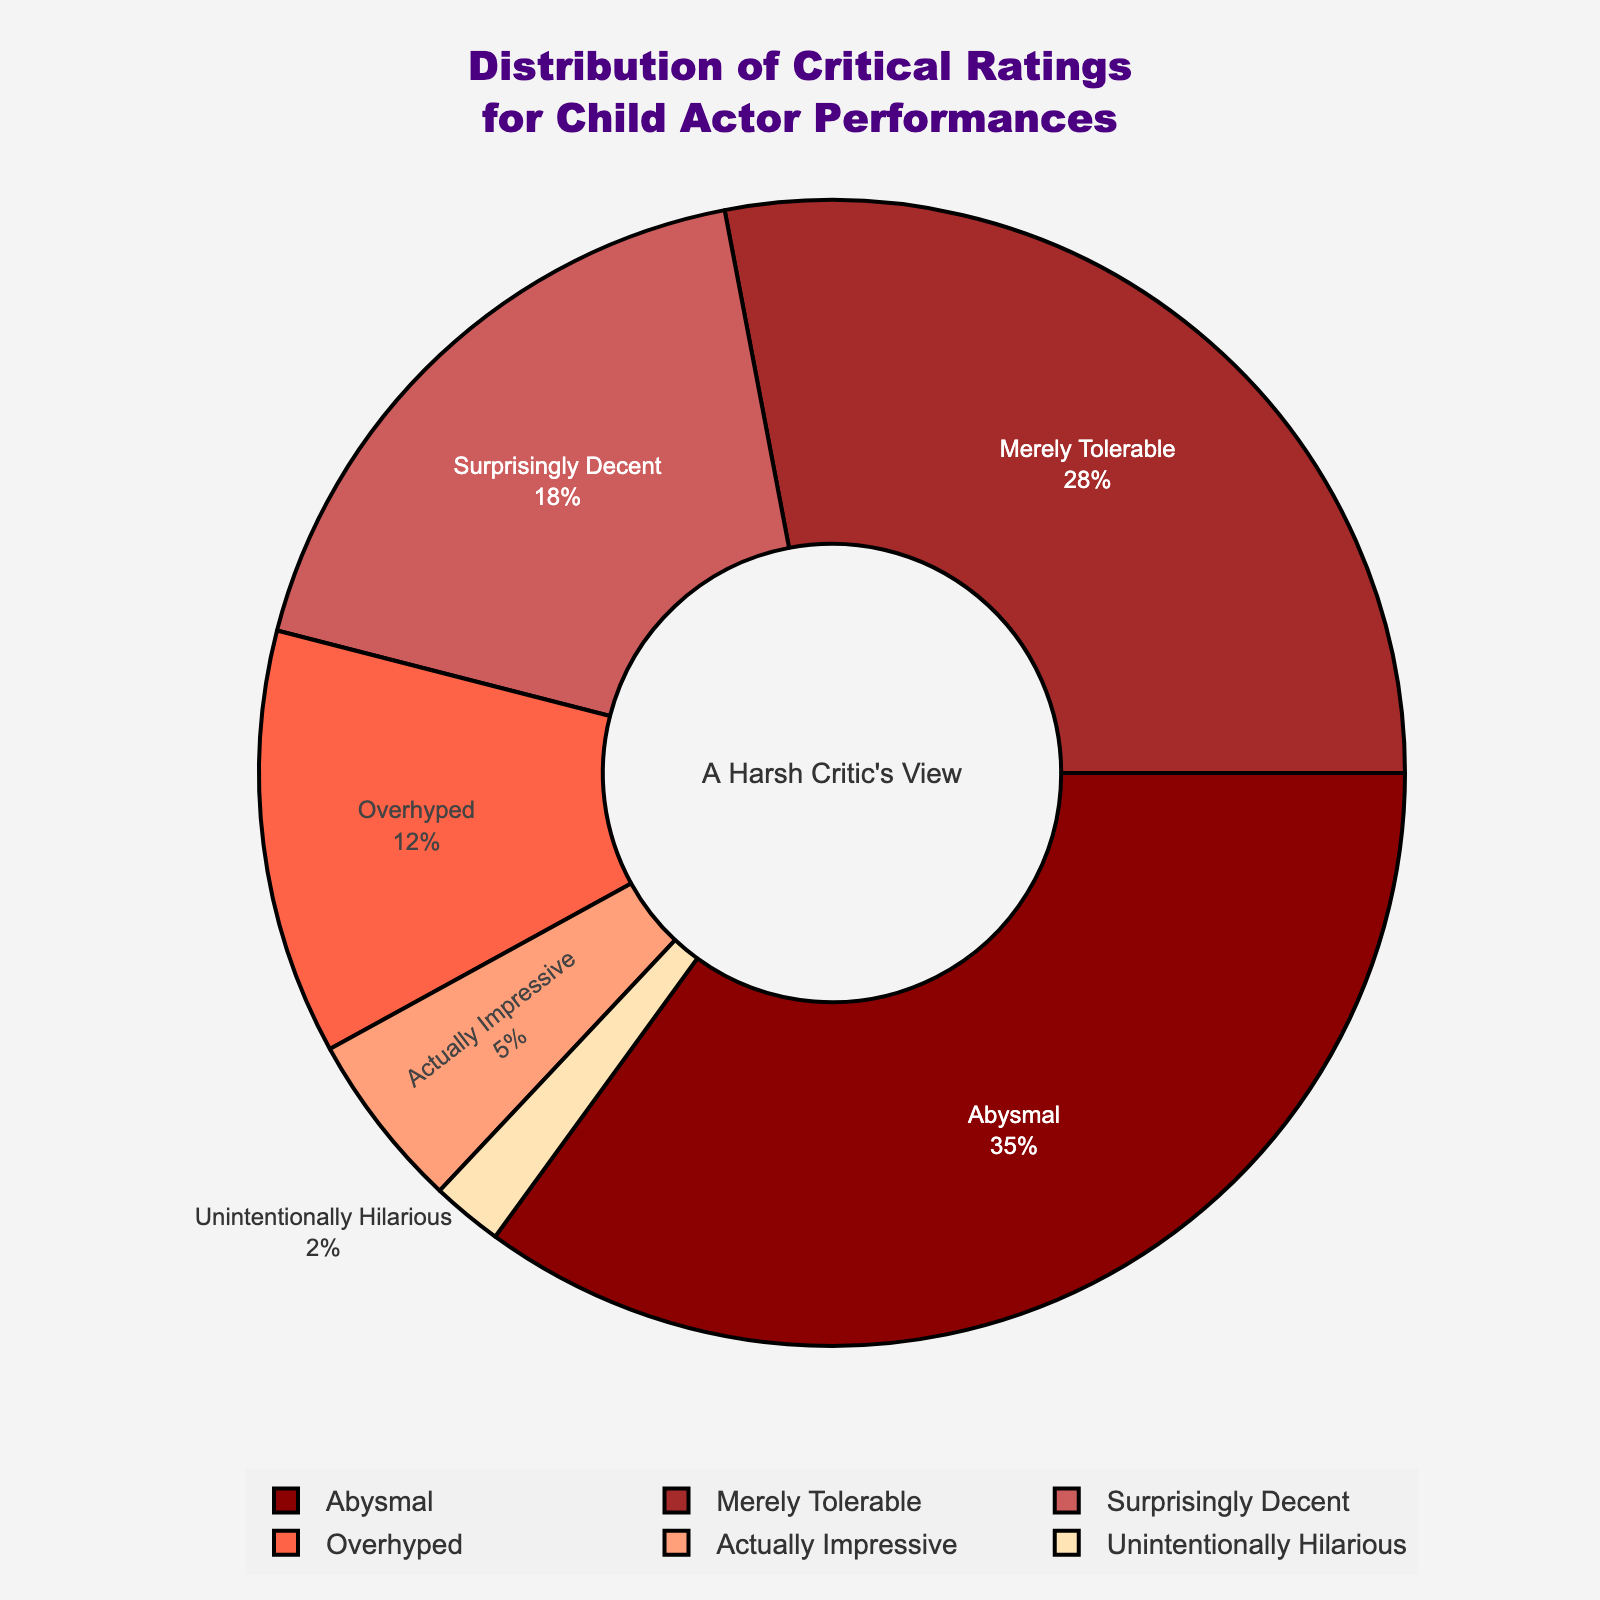What percentage of critical ratings fall into categories that are less than 'Surprisingly Decent'? Add up the percentages of 'Abysmal' (35%) and 'Merely Tolerable' (28%). 35 + 28 = 63%
Answer: 63% Which rating category received the smallest percentage of ratings? Observe the pie chart and note that 'Unintentionally Hilarious' has the smallest slice.
Answer: Unintentionally Hilarious How much greater is the percentage for 'Abysmal' compared to 'Actually Impressive'? Subtract the percentage of 'Actually Impressive' (5%) from 'Abysmal' (35%). 35 - 5 = 30%
Answer: 30% What is the combined percentage of 'Actually Impressive' and 'Overhyped'? Add the percentages for 'Actually Impressive' (5%) and 'Overhyped' (12%). 5 + 12 = 17%
Answer: 17% Which two categories together make up more than 50% of the ratings? The two largest categories are 'Abysmal' (35%) and 'Merely Tolerable' (28%). Their combined percentage is 35 + 28 = 63%, which is more than 50%.
Answer: Abysmal and Merely Tolerable Is the percentage of 'Surprisingly Decent' ratings higher or lower than 'Overhyped'? Compare the percentages: 'Surprisingly Decent' (18%) and 'Overhyped' (12%). Since 18 > 12, 'Surprisingly Decent' is higher.
Answer: Higher By how much does the 'Merely Tolerable' category exceed the 'Overhyped' category in terms of percentage? Subtract the percentage of 'Overhyped' (12%) from 'Merely Tolerable' (28%). 28 - 12 = 16%
Answer: 16% Which three categories combined account for less than 25% of the ratings? Sum the percentages for 'Actually Impressive' (5%), 'Unintentionally Hilarious' (2%), and 'Overhyped' (12%). 5 + 2 + 12 = 19%
Answer: Actually Impressive, Unintentionally Hilarious, and Overhyped What is the difference between the highest and lowest rated categories? Subtract the percentage of the lowest rated category ('Unintentionally Hilarious' at 2%) from the highest rated category ('Abysmal' at 35%). 35 - 2 = 33%
Answer: 33% 